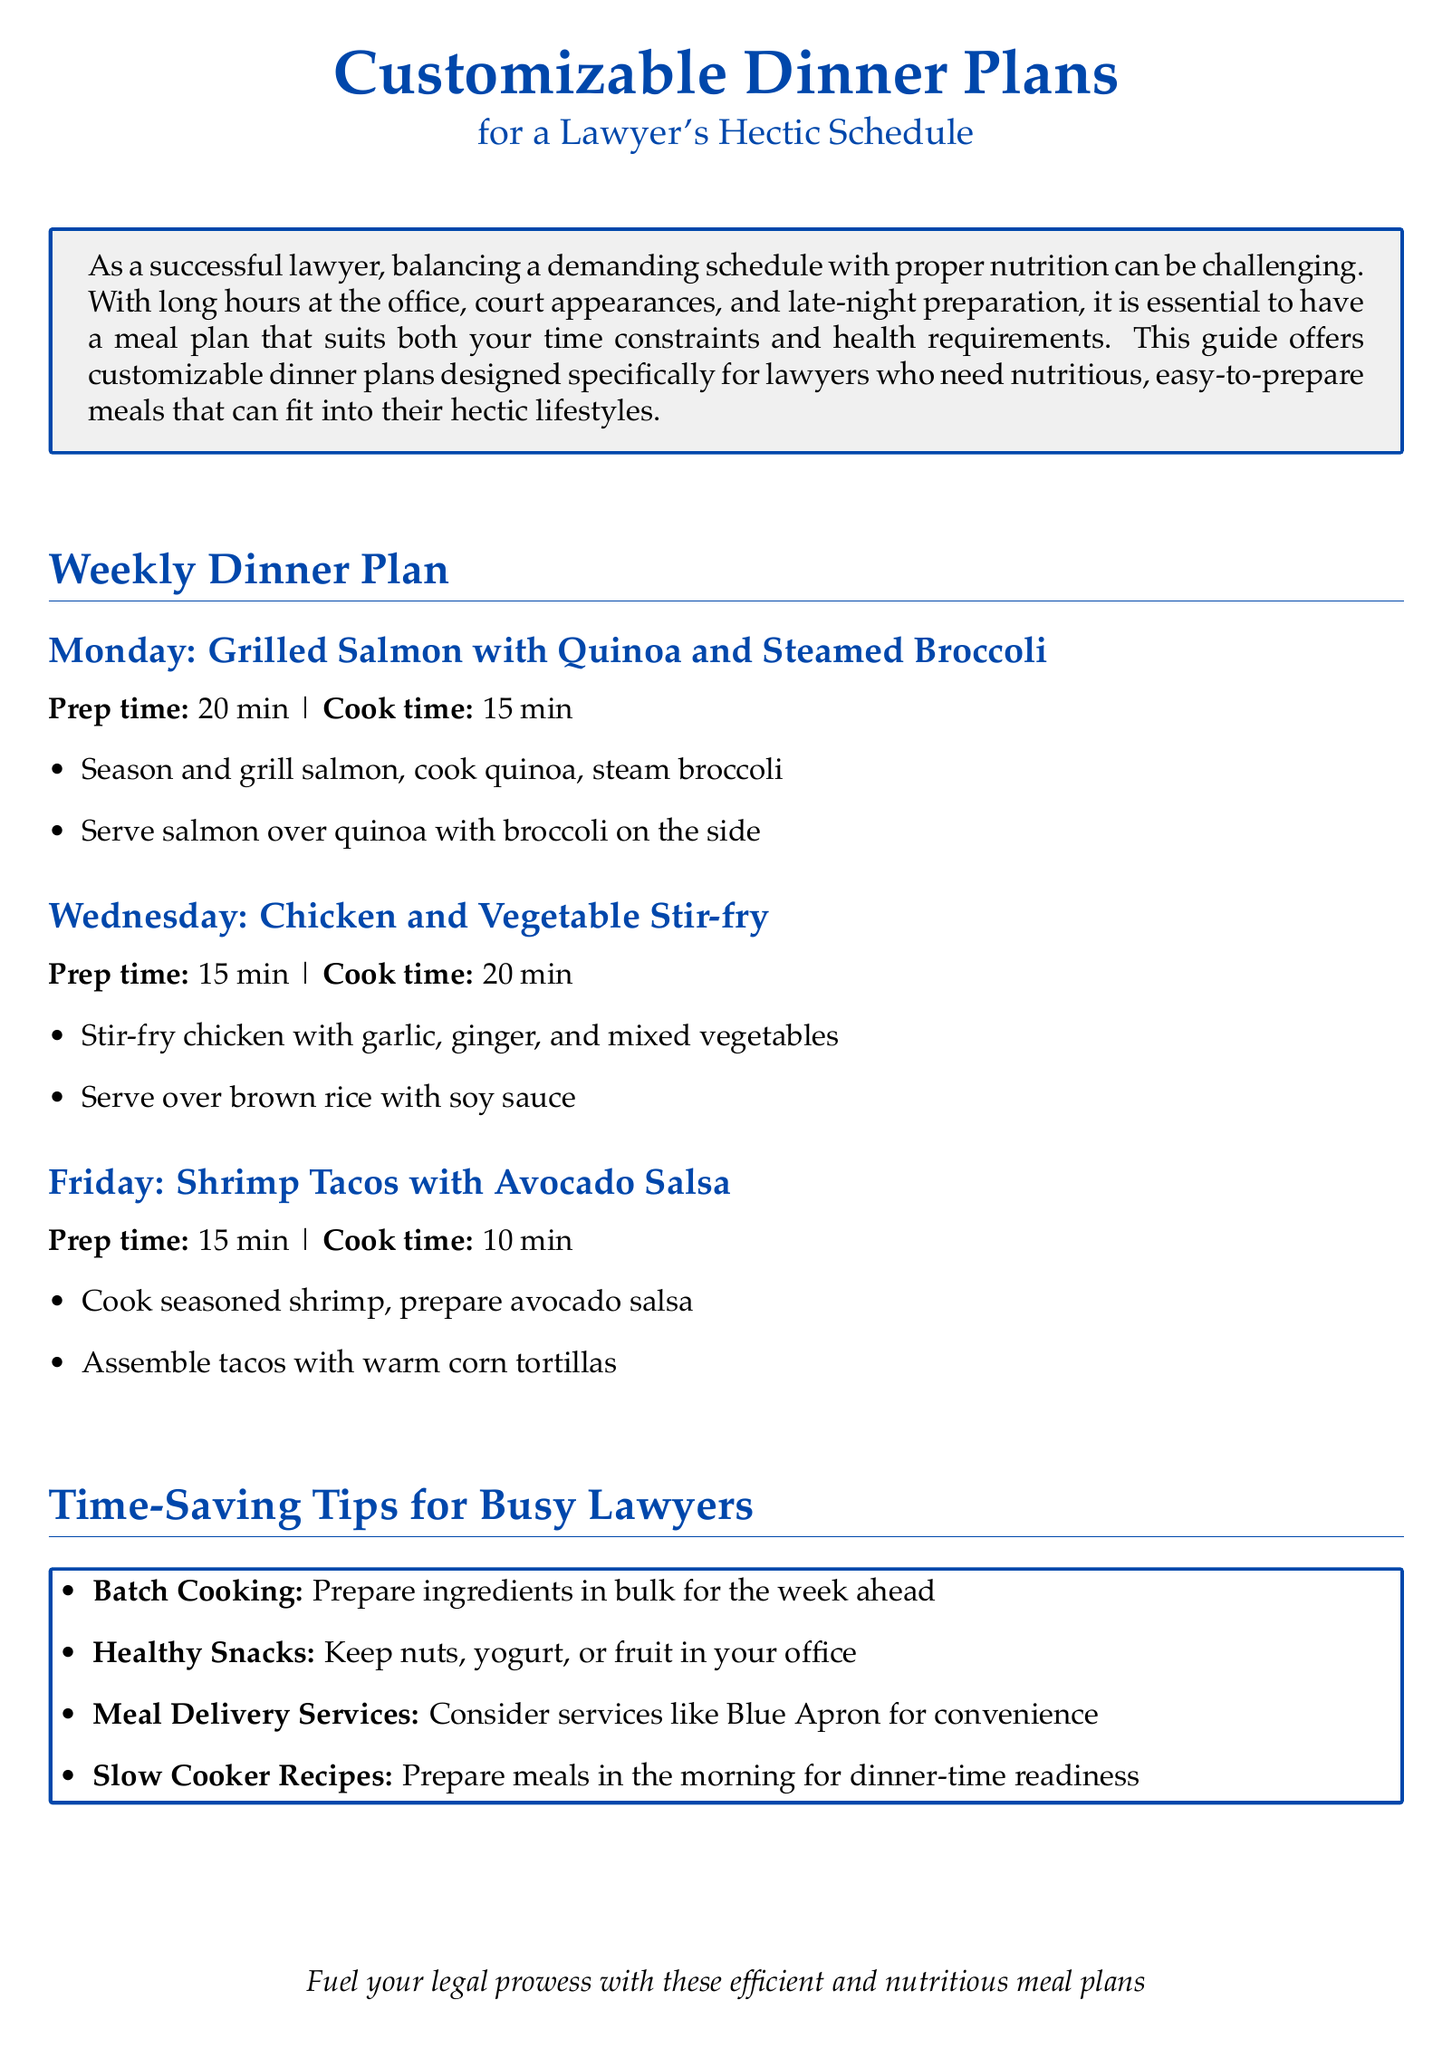What is the main theme of the document? The main theme of the document is to provide customizable dinner plans that cater to a lawyer's hectic schedule.
Answer: Customizable Dinner Plans What is the prep time for Monday's dinner? The prep time for Monday's dinner is stated in the document.
Answer: 20 min What type of fish is included in Monday's meal? The type of fish included in Monday's meal is specifically mentioned.
Answer: Salmon What is one time-saving tip for busy lawyers mentioned? One time-saving tip is explicitly listed in the document.
Answer: Batch Cooking How long does it take to cook the Chicken and Vegetable Stir-fry? The cook time for the Chicken and Vegetable Stir-fry is provided in the document.
Answer: 20 min What day features shrimp tacos? The document specifies the day on which shrimp tacos are served.
Answer: Friday What ingredient is served with the grilled salmon? The document includes details on what is served with the grilled salmon.
Answer: Quinoa What type of recipe is suggested for morning preparation? A specific type of recipe is suggested for making ahead in the morning.
Answer: Slow Cooker Recipes 